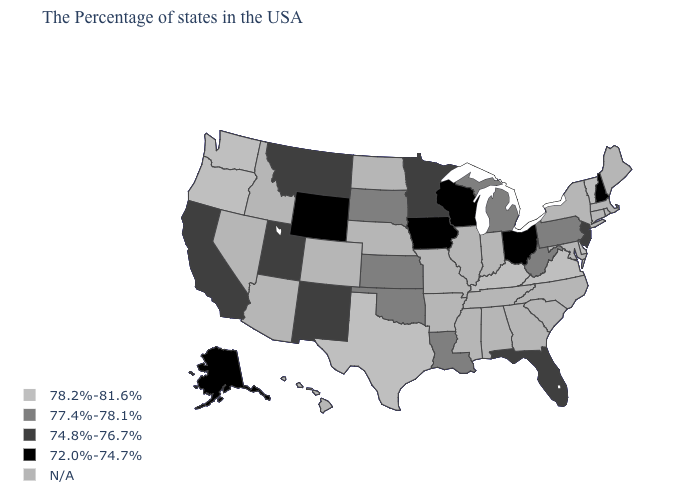Is the legend a continuous bar?
Write a very short answer. No. Name the states that have a value in the range 74.8%-76.7%?
Be succinct. New Jersey, Florida, Minnesota, New Mexico, Utah, Montana, California. What is the value of Kansas?
Keep it brief. 77.4%-78.1%. Which states have the lowest value in the USA?
Concise answer only. New Hampshire, Ohio, Wisconsin, Iowa, Wyoming, Alaska. What is the value of Colorado?
Write a very short answer. N/A. Does the map have missing data?
Write a very short answer. Yes. Is the legend a continuous bar?
Quick response, please. No. Among the states that border New Jersey , does Delaware have the lowest value?
Keep it brief. No. How many symbols are there in the legend?
Give a very brief answer. 5. Among the states that border Arkansas , does Oklahoma have the lowest value?
Keep it brief. Yes. Name the states that have a value in the range 78.2%-81.6%?
Keep it brief. Vermont, Delaware, Virginia, Kentucky, Texas, Washington, Oregon. Does Pennsylvania have the lowest value in the USA?
Answer briefly. No. What is the value of Florida?
Give a very brief answer. 74.8%-76.7%. 